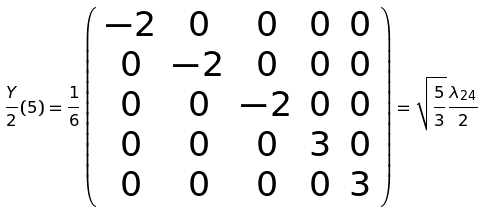<formula> <loc_0><loc_0><loc_500><loc_500>\frac { Y } { 2 } ( { 5 } ) = \frac { 1 } { 6 } \left ( \begin{array} { c c c c c } - 2 & 0 & 0 & 0 & 0 \\ 0 & - 2 & 0 & 0 & 0 \\ 0 & 0 & - 2 & 0 & 0 \\ 0 & 0 & 0 & 3 & 0 \\ 0 & 0 & 0 & 0 & 3 \end{array} \right ) = \sqrt { \frac { 5 } { 3 } } \frac { \lambda _ { 2 4 } } { 2 }</formula> 